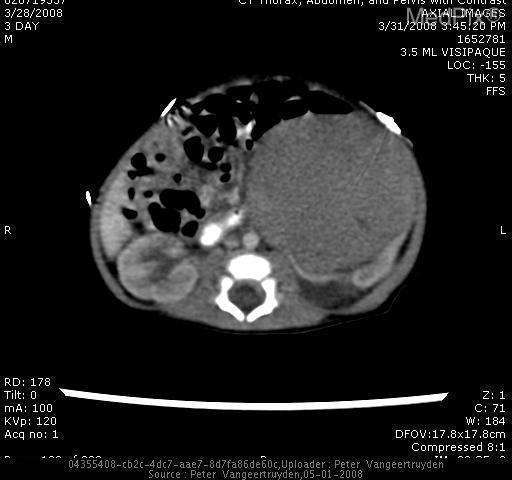Is the patient's kidney this large mass to the right?
Be succinct. Yes. Are there multiple masses or just a single big one?
Write a very short answer. Just one. Is the left kidney affected?
Concise answer only. No. 